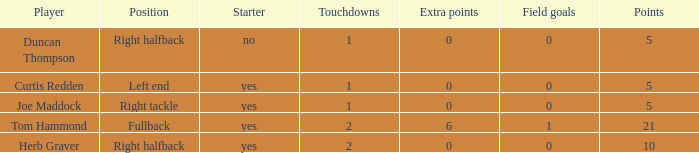Name the starter for position being left end Yes. 